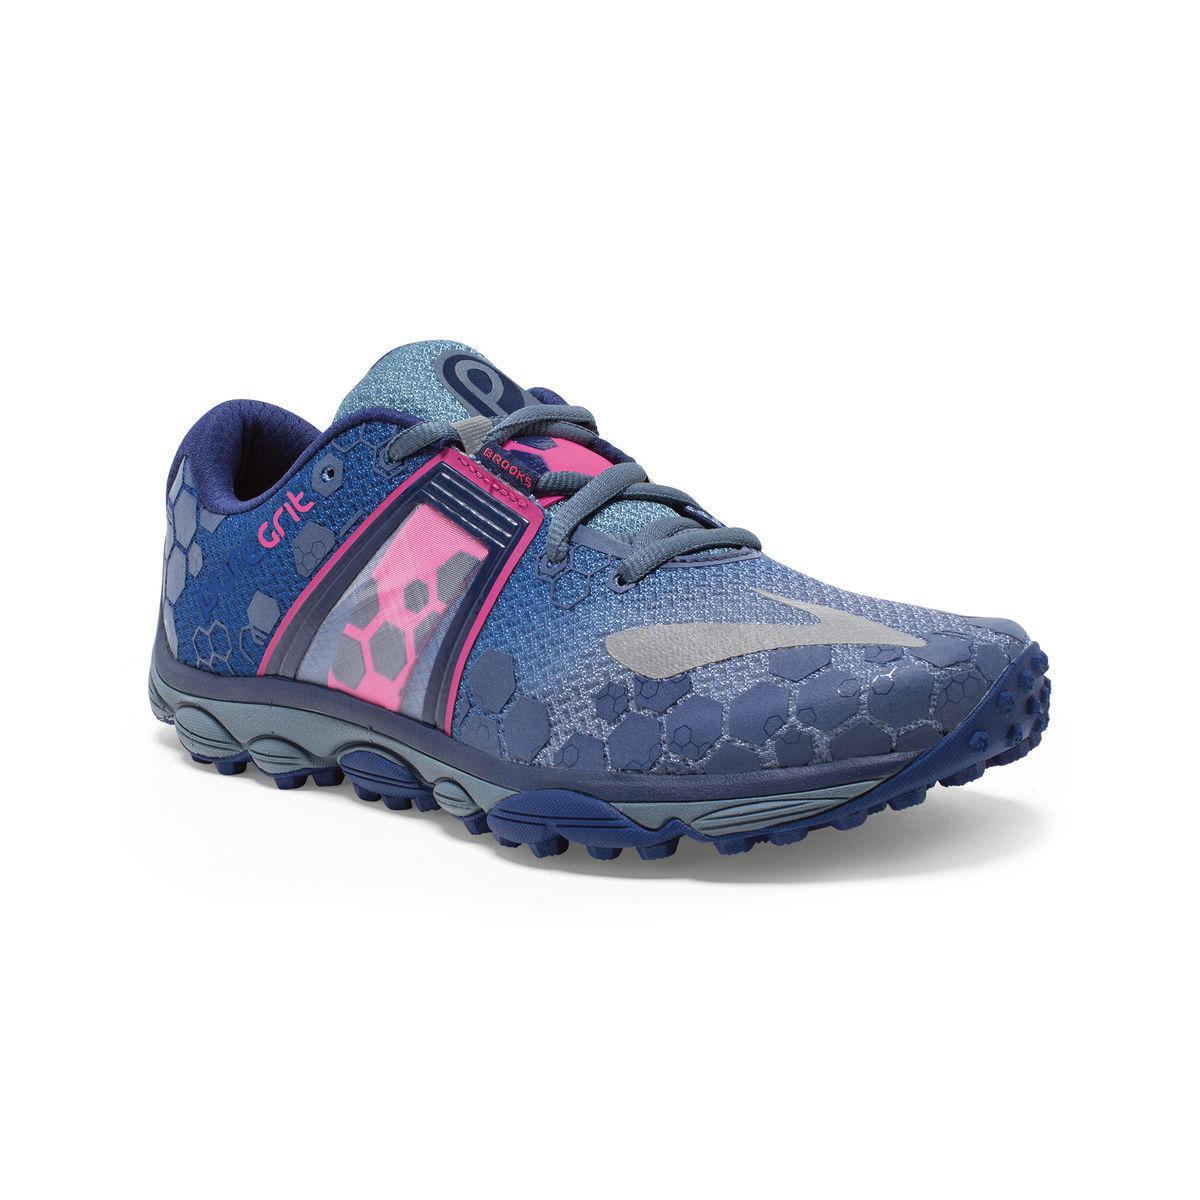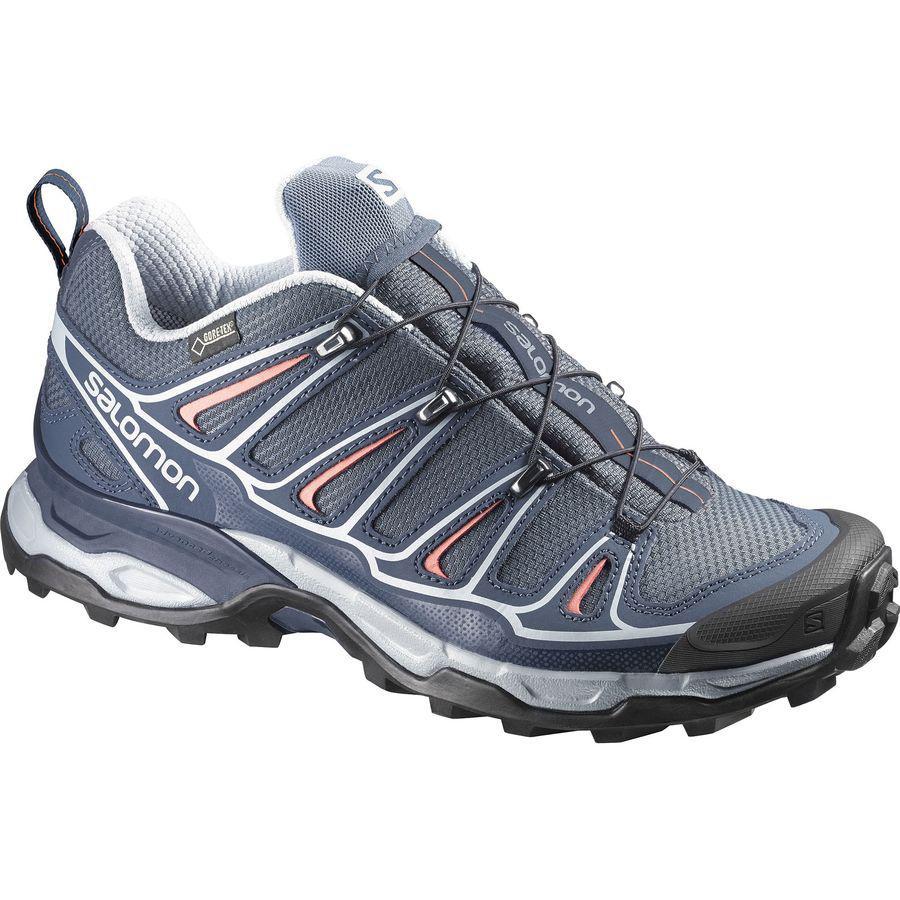The first image is the image on the left, the second image is the image on the right. For the images shown, is this caption "One of the shoes has the laces tied in a bow." true? Answer yes or no. No. The first image is the image on the left, the second image is the image on the right. Considering the images on both sides, is "The shoe on the left has laces tied into a bow while the shoe on the right has laces that tighten without tying." valid? Answer yes or no. No. 